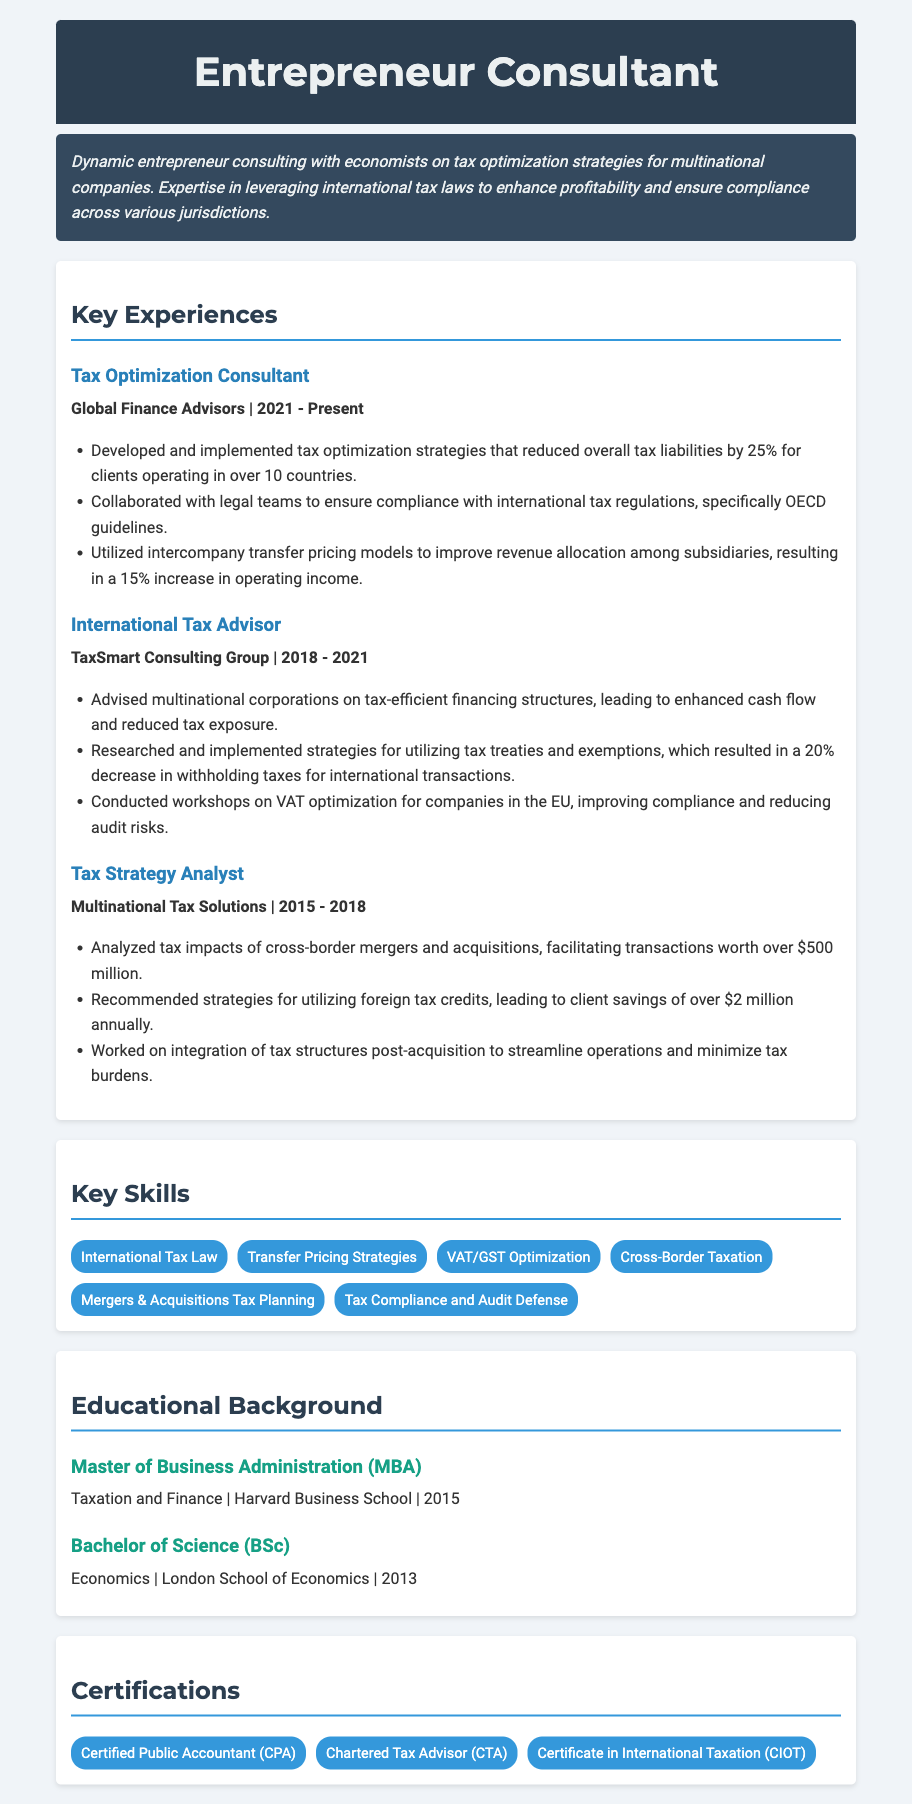what position does the consultant currently hold? The document states that the current position is "Tax Optimization Consultant."
Answer: Tax Optimization Consultant which company did the consultant work for from 2018 to 2021? The experience section reveals that the consultant worked for "TaxSmart Consulting Group" during that time frame.
Answer: TaxSmart Consulting Group what percentage did tax optimization strategies reduce liabilities by? The document specifies that tax optimization strategies reduced overall tax liabilities by 25%.
Answer: 25% what was a primary outcome of utilizing intercompany transfer pricing models? According to the document, this resulted in a 15% increase in operating income.
Answer: 15% how many countries were involved in the tax optimization strategies? The document mentions that the consultant worked with clients operating in over 10 countries.
Answer: over 10 countries what degree did the consultant obtain from Harvard Business School? The educational background section states that the consultant received an MBA.
Answer: MBA which certification is mentioned first in the certifications section? The first certification listed is "Certified Public Accountant (CPA)."
Answer: Certified Public Accountant (CPA) who collaborated with the consultant to ensure compliance with tax regulations? The document indicates that the consultant collaborated with legal teams for this purpose.
Answer: legal teams what was the focus of the workshops conducted by the consultant? The document specifies that the workshops were focused on "VAT optimization."
Answer: VAT optimization 